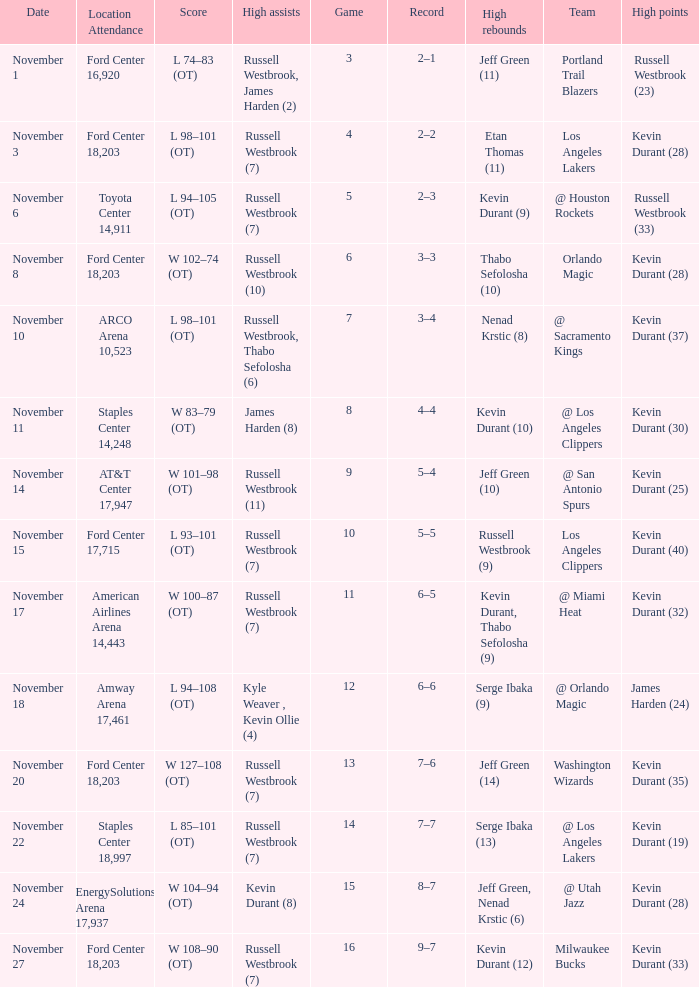When was the game number 3 played? November 1. 